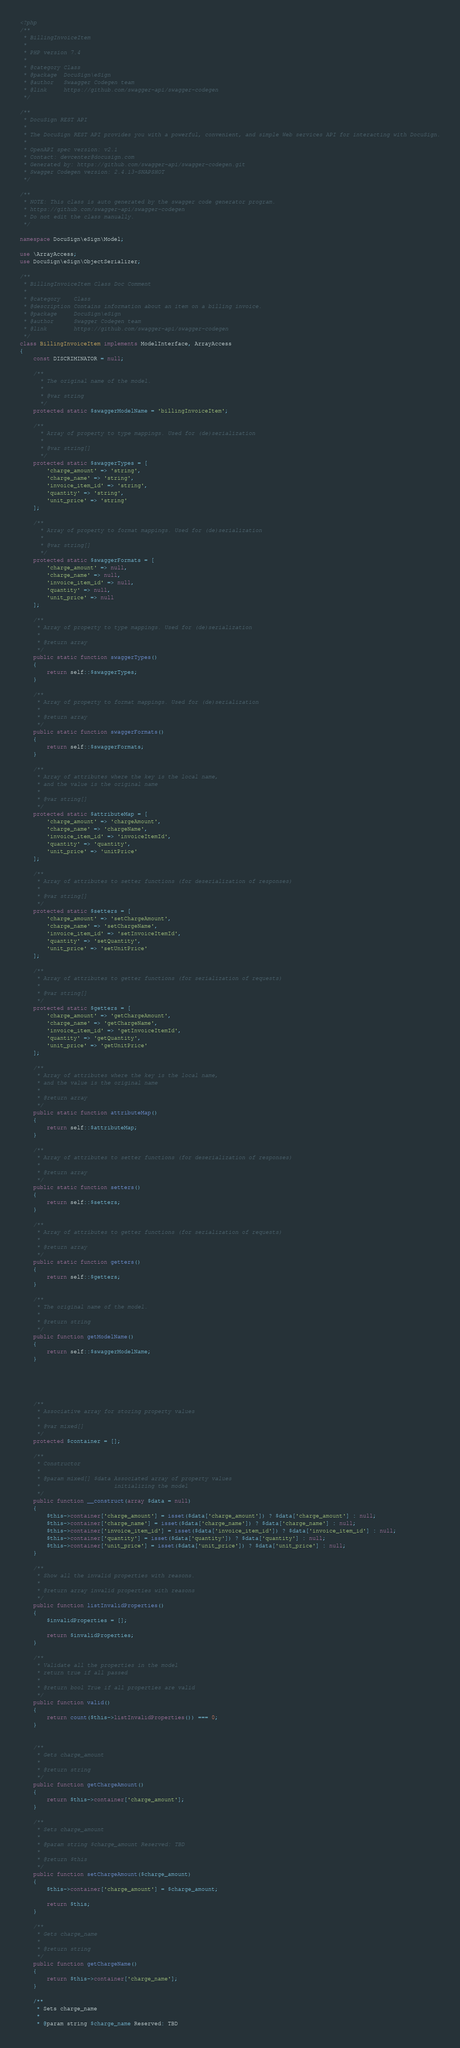Convert code to text. <code><loc_0><loc_0><loc_500><loc_500><_PHP_><?php
/**
 * BillingInvoiceItem
 *
 * PHP version 7.4
 *
 * @category Class
 * @package  DocuSign\eSign
 * @author   Swaagger Codegen team
 * @link     https://github.com/swagger-api/swagger-codegen
 */

/**
 * DocuSign REST API
 *
 * The DocuSign REST API provides you with a powerful, convenient, and simple Web services API for interacting with DocuSign.
 *
 * OpenAPI spec version: v2.1
 * Contact: devcenter@docusign.com
 * Generated by: https://github.com/swagger-api/swagger-codegen.git
 * Swagger Codegen version: 2.4.13-SNAPSHOT
 */

/**
 * NOTE: This class is auto generated by the swagger code generator program.
 * https://github.com/swagger-api/swagger-codegen
 * Do not edit the class manually.
 */

namespace DocuSign\eSign\Model;

use \ArrayAccess;
use DocuSign\eSign\ObjectSerializer;

/**
 * BillingInvoiceItem Class Doc Comment
 *
 * @category    Class
 * @description Contains information about an item on a billing invoice.
 * @package     DocuSign\eSign
 * @author      Swagger Codegen team
 * @link        https://github.com/swagger-api/swagger-codegen
 */
class BillingInvoiceItem implements ModelInterface, ArrayAccess
{
    const DISCRIMINATOR = null;

    /**
      * The original name of the model.
      *
      * @var string
      */
    protected static $swaggerModelName = 'billingInvoiceItem';

    /**
      * Array of property to type mappings. Used for (de)serialization
      *
      * @var string[]
      */
    protected static $swaggerTypes = [
        'charge_amount' => 'string',
        'charge_name' => 'string',
        'invoice_item_id' => 'string',
        'quantity' => 'string',
        'unit_price' => 'string'
    ];

    /**
      * Array of property to format mappings. Used for (de)serialization
      *
      * @var string[]
      */
    protected static $swaggerFormats = [
        'charge_amount' => null,
        'charge_name' => null,
        'invoice_item_id' => null,
        'quantity' => null,
        'unit_price' => null
    ];

    /**
     * Array of property to type mappings. Used for (de)serialization
     *
     * @return array
     */
    public static function swaggerTypes()
    {
        return self::$swaggerTypes;
    }

    /**
     * Array of property to format mappings. Used for (de)serialization
     *
     * @return array
     */
    public static function swaggerFormats()
    {
        return self::$swaggerFormats;
    }

    /**
     * Array of attributes where the key is the local name,
     * and the value is the original name
     *
     * @var string[]
     */
    protected static $attributeMap = [
        'charge_amount' => 'chargeAmount',
        'charge_name' => 'chargeName',
        'invoice_item_id' => 'invoiceItemId',
        'quantity' => 'quantity',
        'unit_price' => 'unitPrice'
    ];

    /**
     * Array of attributes to setter functions (for deserialization of responses)
     *
     * @var string[]
     */
    protected static $setters = [
        'charge_amount' => 'setChargeAmount',
        'charge_name' => 'setChargeName',
        'invoice_item_id' => 'setInvoiceItemId',
        'quantity' => 'setQuantity',
        'unit_price' => 'setUnitPrice'
    ];

    /**
     * Array of attributes to getter functions (for serialization of requests)
     *
     * @var string[]
     */
    protected static $getters = [
        'charge_amount' => 'getChargeAmount',
        'charge_name' => 'getChargeName',
        'invoice_item_id' => 'getInvoiceItemId',
        'quantity' => 'getQuantity',
        'unit_price' => 'getUnitPrice'
    ];

    /**
     * Array of attributes where the key is the local name,
     * and the value is the original name
     *
     * @return array
     */
    public static function attributeMap()
    {
        return self::$attributeMap;
    }

    /**
     * Array of attributes to setter functions (for deserialization of responses)
     *
     * @return array
     */
    public static function setters()
    {
        return self::$setters;
    }

    /**
     * Array of attributes to getter functions (for serialization of requests)
     *
     * @return array
     */
    public static function getters()
    {
        return self::$getters;
    }

    /**
     * The original name of the model.
     *
     * @return string
     */
    public function getModelName()
    {
        return self::$swaggerModelName;
    }

    

    

    /**
     * Associative array for storing property values
     *
     * @var mixed[]
     */
    protected $container = [];

    /**
     * Constructor
     *
     * @param mixed[] $data Associated array of property values
     *                      initializing the model
     */
    public function __construct(array $data = null)
    {
        $this->container['charge_amount'] = isset($data['charge_amount']) ? $data['charge_amount'] : null;
        $this->container['charge_name'] = isset($data['charge_name']) ? $data['charge_name'] : null;
        $this->container['invoice_item_id'] = isset($data['invoice_item_id']) ? $data['invoice_item_id'] : null;
        $this->container['quantity'] = isset($data['quantity']) ? $data['quantity'] : null;
        $this->container['unit_price'] = isset($data['unit_price']) ? $data['unit_price'] : null;
    }

    /**
     * Show all the invalid properties with reasons.
     *
     * @return array invalid properties with reasons
     */
    public function listInvalidProperties()
    {
        $invalidProperties = [];

        return $invalidProperties;
    }

    /**
     * Validate all the properties in the model
     * return true if all passed
     *
     * @return bool True if all properties are valid
     */
    public function valid()
    {
        return count($this->listInvalidProperties()) === 0;
    }


    /**
     * Gets charge_amount
     *
     * @return string
     */
    public function getChargeAmount()
    {
        return $this->container['charge_amount'];
    }

    /**
     * Sets charge_amount
     *
     * @param string $charge_amount Reserved: TBD
     *
     * @return $this
     */
    public function setChargeAmount($charge_amount)
    {
        $this->container['charge_amount'] = $charge_amount;

        return $this;
    }

    /**
     * Gets charge_name
     *
     * @return string
     */
    public function getChargeName()
    {
        return $this->container['charge_name'];
    }

    /**
     * Sets charge_name
     *
     * @param string $charge_name Reserved: TBD</code> 